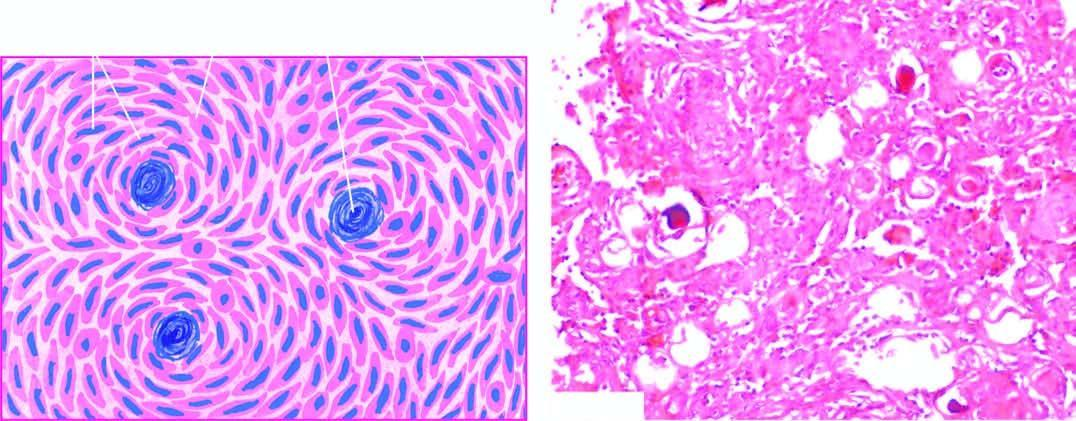do some of the whorls contain psammoma bodies?
Answer the question using a single word or phrase. Yes 